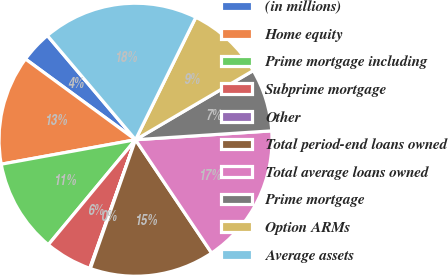Convert chart. <chart><loc_0><loc_0><loc_500><loc_500><pie_chart><fcel>(in millions)<fcel>Home equity<fcel>Prime mortgage including<fcel>Subprime mortgage<fcel>Other<fcel>Total period-end loans owned<fcel>Total average loans owned<fcel>Prime mortgage<fcel>Option ARMs<fcel>Average assets<nl><fcel>3.75%<fcel>12.94%<fcel>11.1%<fcel>5.59%<fcel>0.07%<fcel>14.78%<fcel>16.62%<fcel>7.42%<fcel>9.26%<fcel>18.46%<nl></chart> 